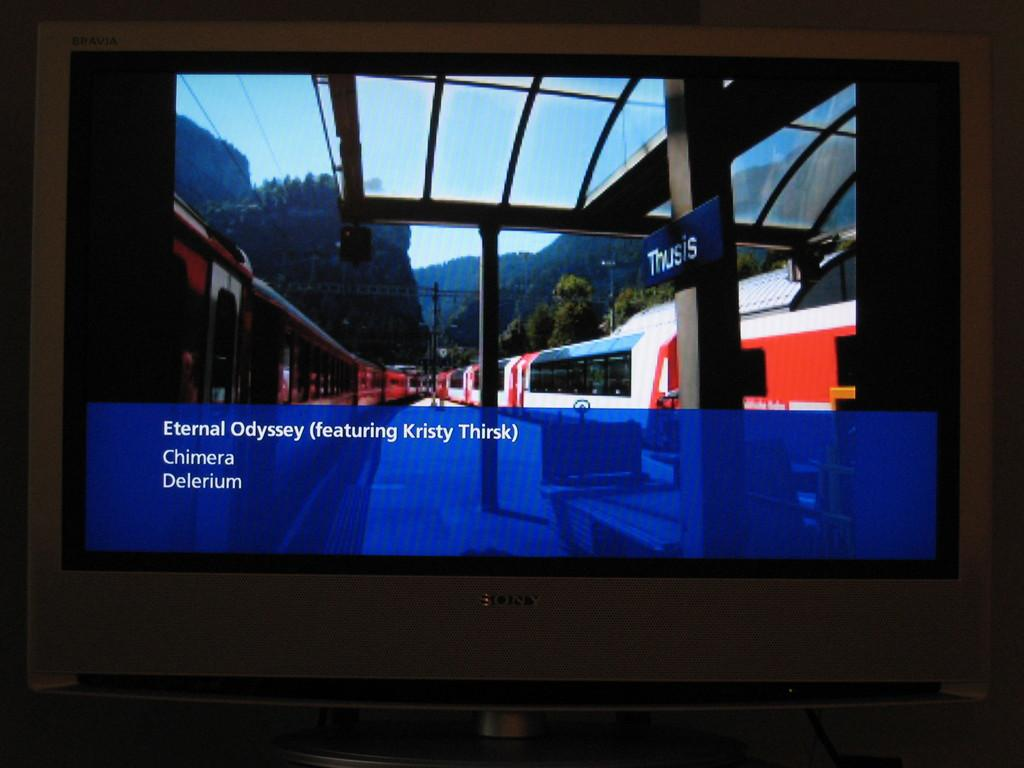<image>
Offer a succinct explanation of the picture presented. Screen which starts off by saying "Eternal Odyssey". 